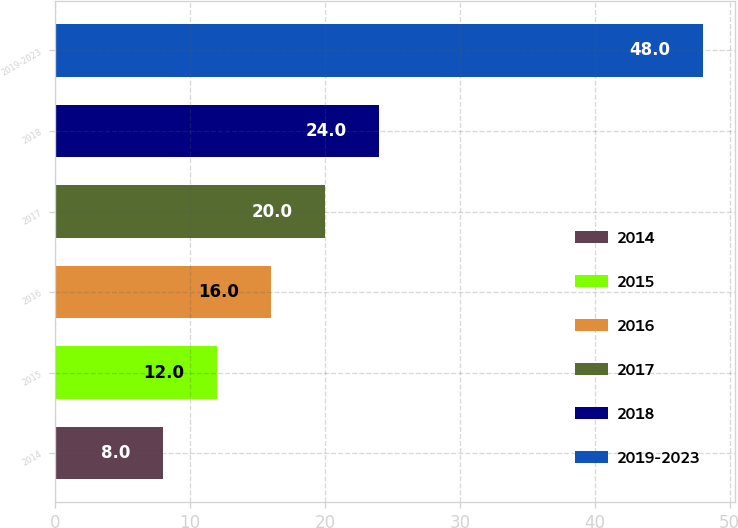Convert chart to OTSL. <chart><loc_0><loc_0><loc_500><loc_500><bar_chart><fcel>2014<fcel>2015<fcel>2016<fcel>2017<fcel>2018<fcel>2019-2023<nl><fcel>8<fcel>12<fcel>16<fcel>20<fcel>24<fcel>48<nl></chart> 